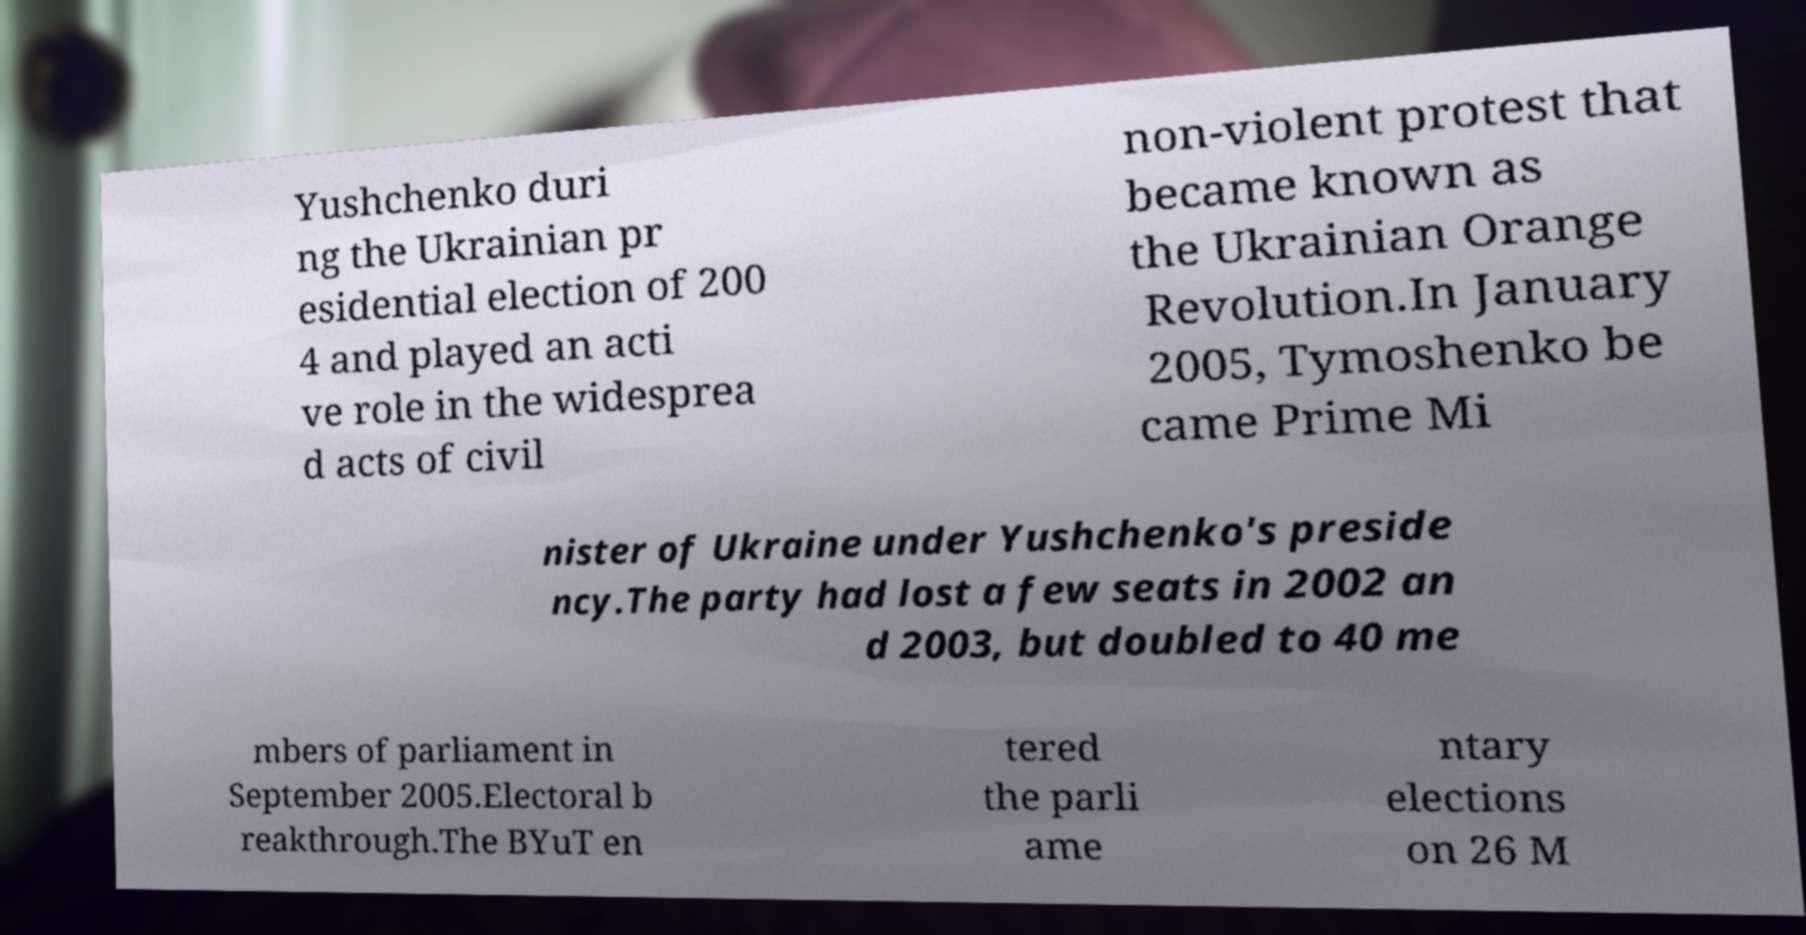What messages or text are displayed in this image? I need them in a readable, typed format. Yushchenko duri ng the Ukrainian pr esidential election of 200 4 and played an acti ve role in the widesprea d acts of civil non-violent protest that became known as the Ukrainian Orange Revolution.In January 2005, Tymoshenko be came Prime Mi nister of Ukraine under Yushchenko's preside ncy.The party had lost a few seats in 2002 an d 2003, but doubled to 40 me mbers of parliament in September 2005.Electoral b reakthrough.The BYuT en tered the parli ame ntary elections on 26 M 